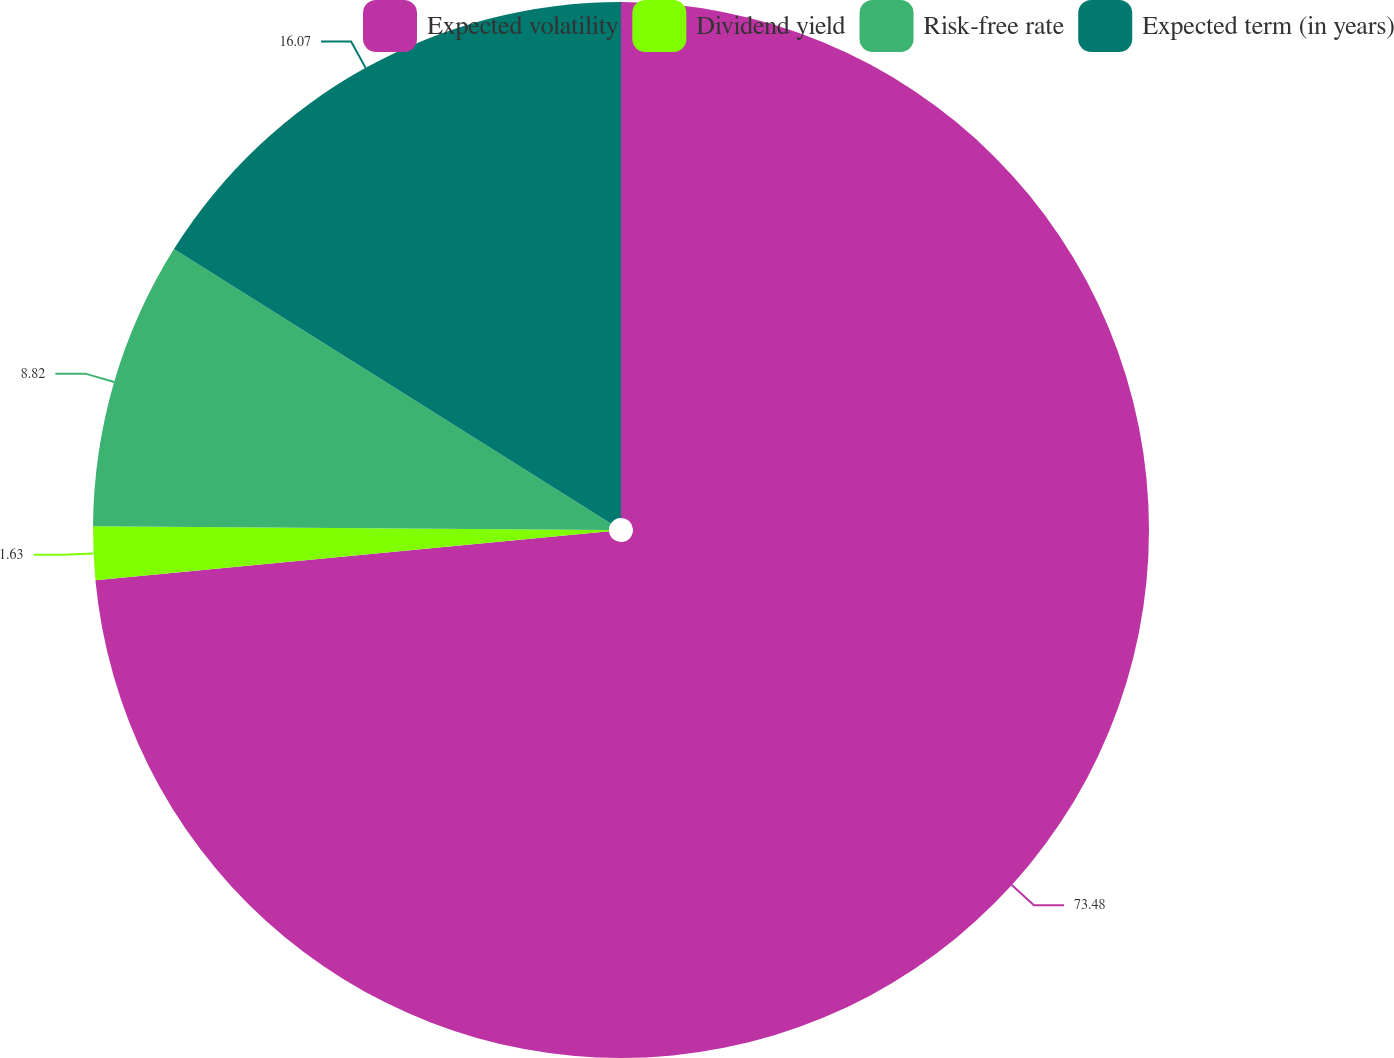Convert chart to OTSL. <chart><loc_0><loc_0><loc_500><loc_500><pie_chart><fcel>Expected volatility<fcel>Dividend yield<fcel>Risk-free rate<fcel>Expected term (in years)<nl><fcel>73.48%<fcel>1.63%<fcel>8.82%<fcel>16.07%<nl></chart> 